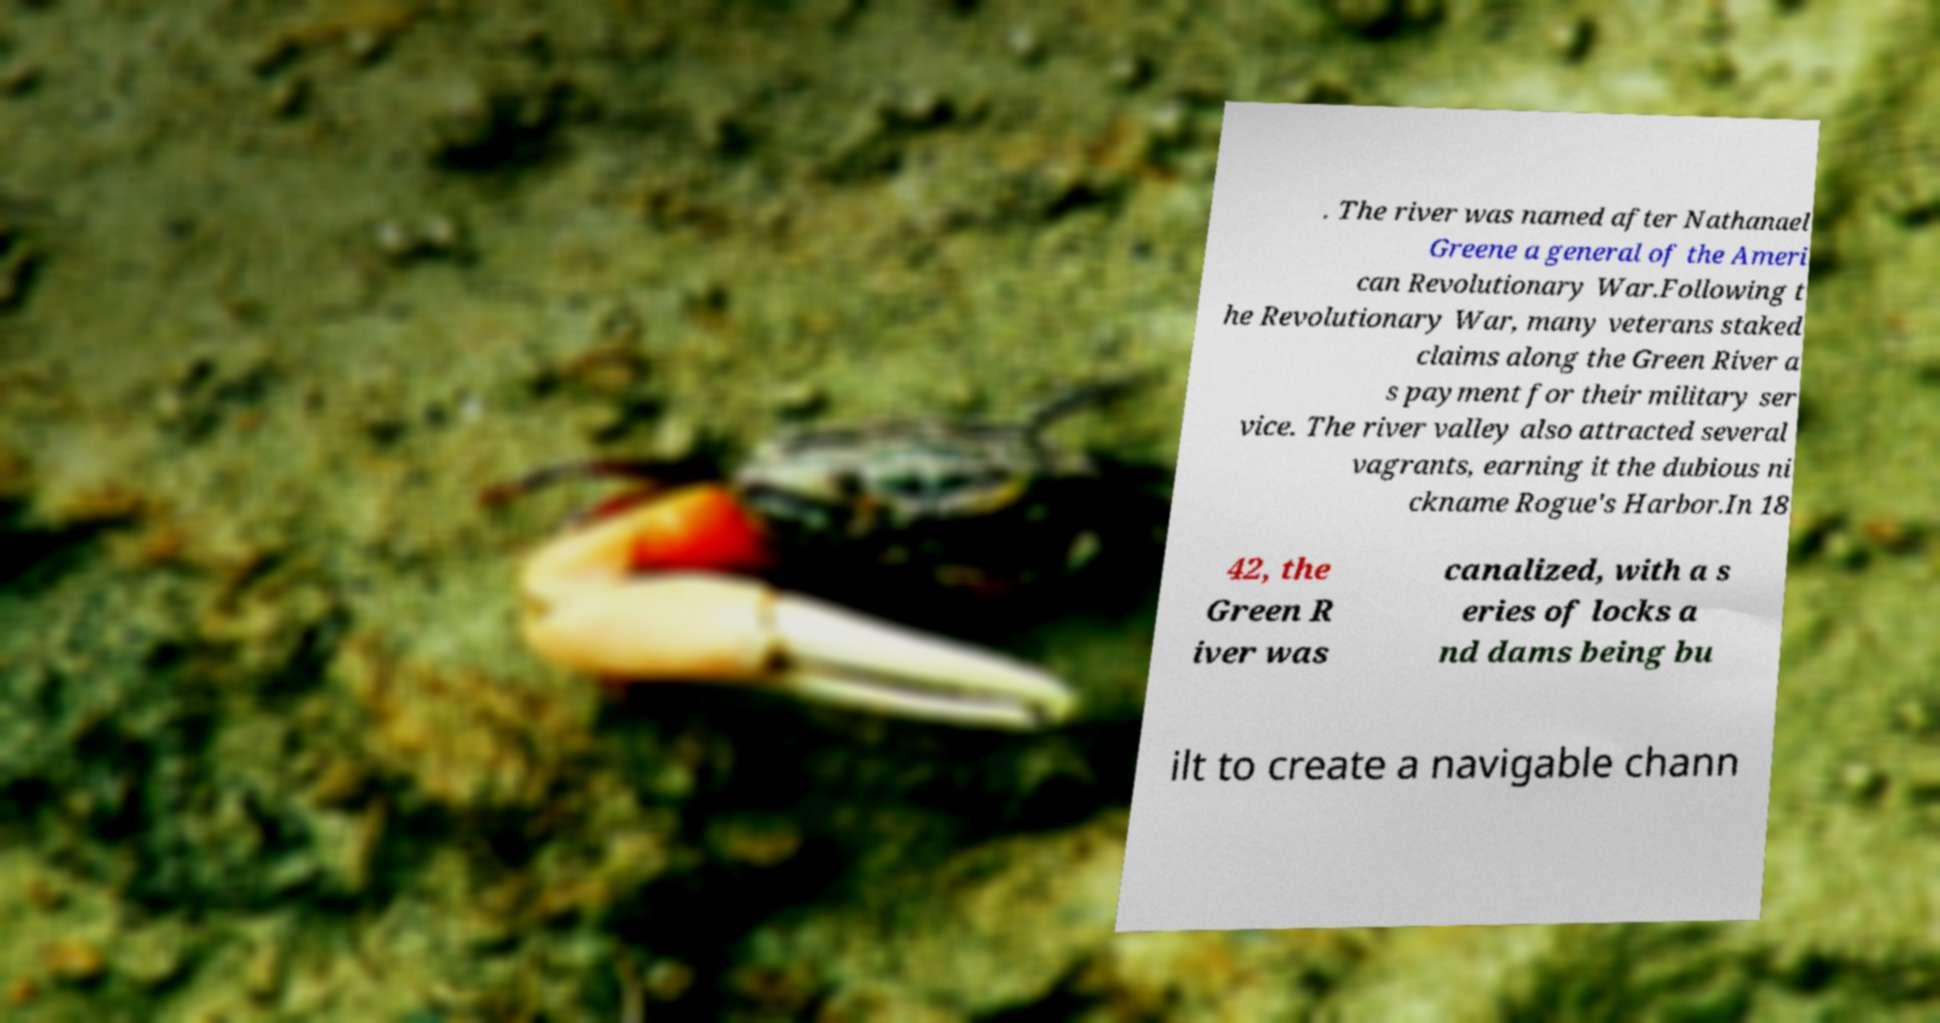Can you accurately transcribe the text from the provided image for me? . The river was named after Nathanael Greene a general of the Ameri can Revolutionary War.Following t he Revolutionary War, many veterans staked claims along the Green River a s payment for their military ser vice. The river valley also attracted several vagrants, earning it the dubious ni ckname Rogue's Harbor.In 18 42, the Green R iver was canalized, with a s eries of locks a nd dams being bu ilt to create a navigable chann 